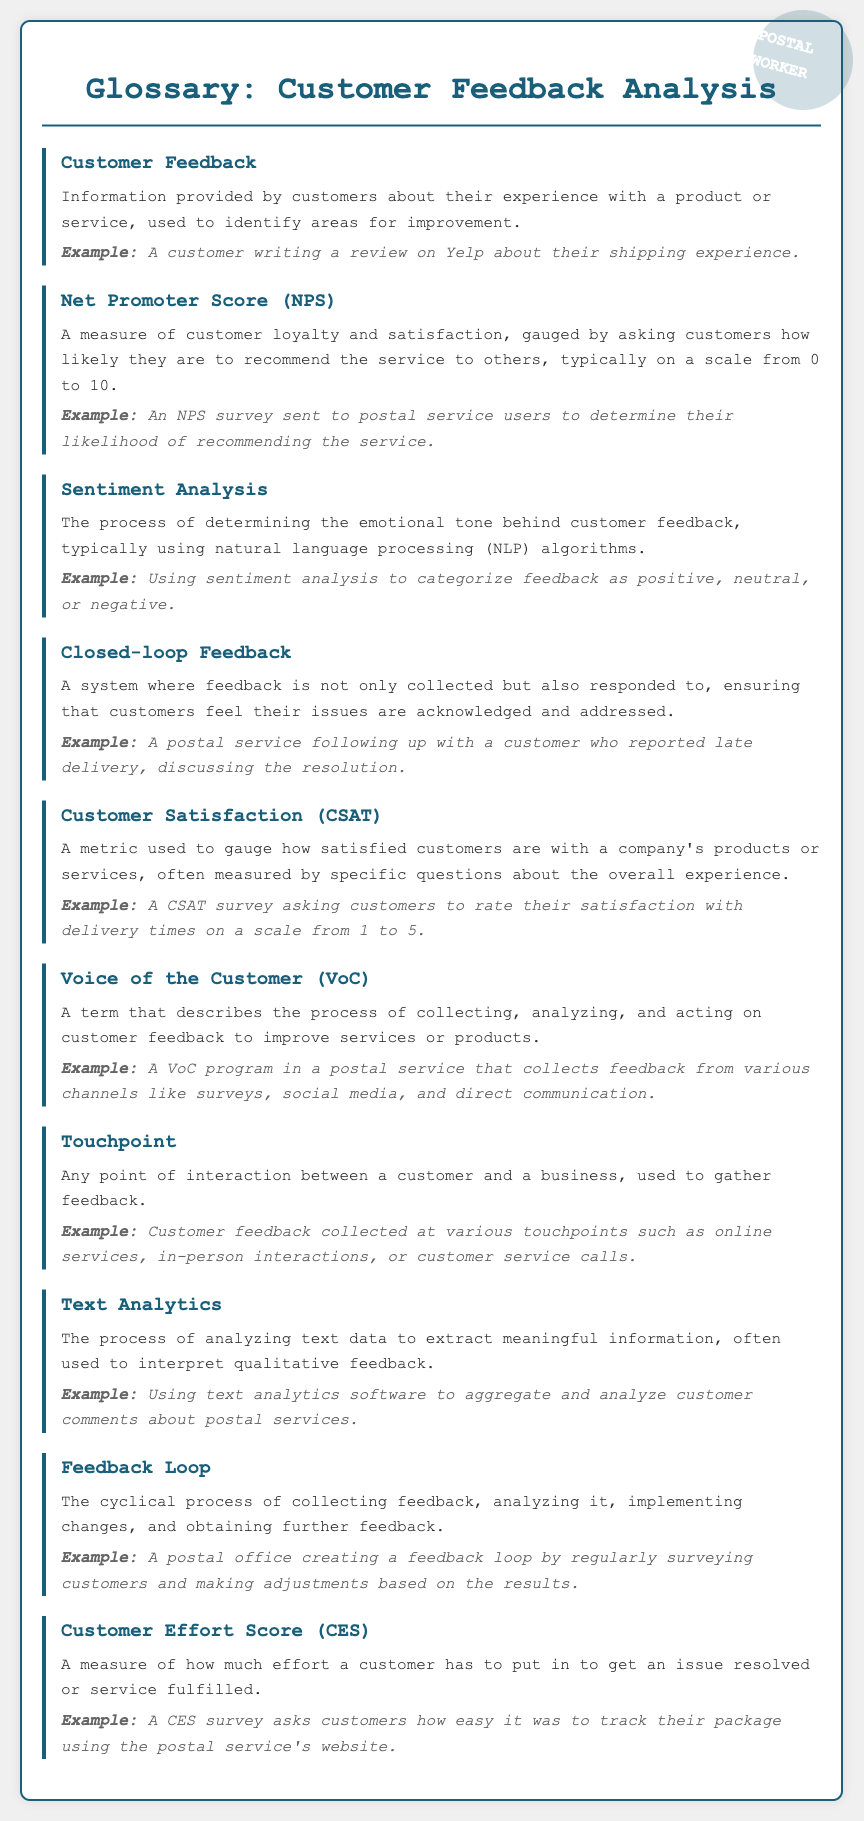what is the term that describes customer experience feedback? The document defines customer feedback as information provided by customers about their experience with a product or service.
Answer: Customer Feedback what metric is used to measure customer loyalty? The document mentions Net Promoter Score (NPS) as a measure of customer loyalty and satisfaction.
Answer: Net Promoter Score (NPS) how is customer satisfaction measured in the document? Customer Satisfaction (CSAT) is described as a metric used to gauge satisfaction, often measured by specific questions about the overall experience.
Answer: Customer Satisfaction (CSAT) what process determines the emotional tone behind customer feedback? The document refers to the process of determining the emotional tone as Sentiment Analysis, typically using NLP algorithms.
Answer: Sentiment Analysis which term refers to the collection and analysis of customer feedback? The document specifies Voice of the Customer (VoC) as the process of collecting, analyzing, and acting on feedback.
Answer: Voice of the Customer (VoC) what is consulted to gather feedback during customer interactions? The document mentions touchpoints as any point of interaction between a customer and a business for feedback collection.
Answer: Touchpoint which concept represents a cycle of collecting and responding to feedback? The document describes the Feedback Loop as the cyclical process of collecting feedback and implementing changes.
Answer: Feedback Loop how is the effort required from a customer quantified in feedback surveys? The Customer Effort Score (CES) is referenced in the document as a measure of customer effort in obtaining services.
Answer: Customer Effort Score (CES) what analysis is used to interpret qualitative feedback in text form? The document states that Text Analytics is the process used to analyze text data and extract information from qualitative feedback.
Answer: Text Analytics 